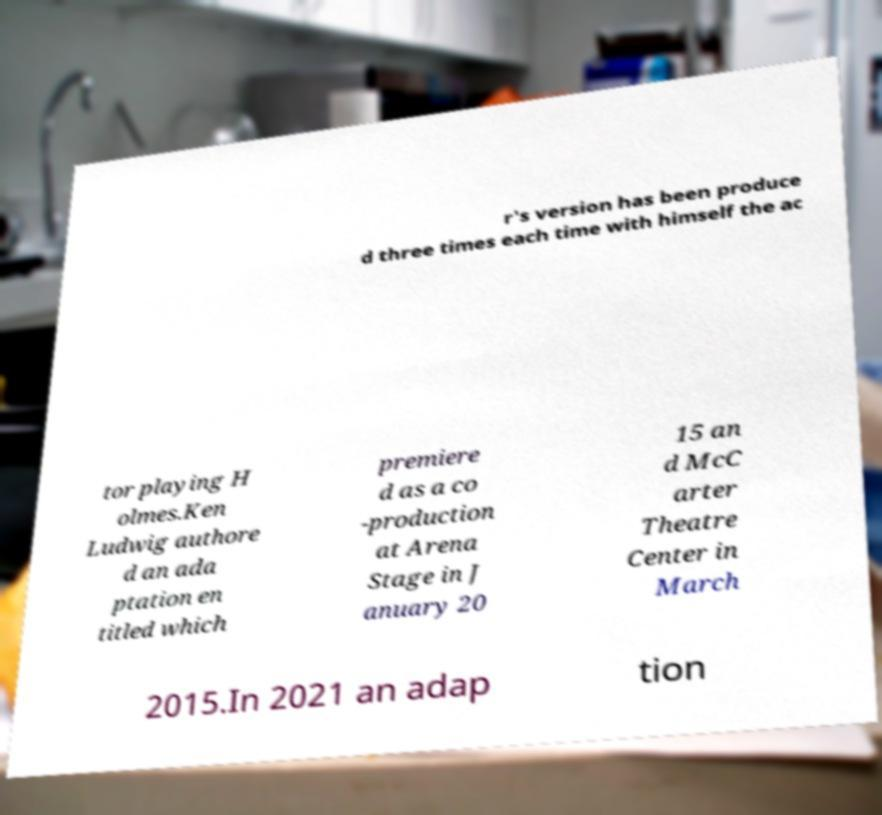Could you extract and type out the text from this image? r's version has been produce d three times each time with himself the ac tor playing H olmes.Ken Ludwig authore d an ada ptation en titled which premiere d as a co -production at Arena Stage in J anuary 20 15 an d McC arter Theatre Center in March 2015.In 2021 an adap tion 